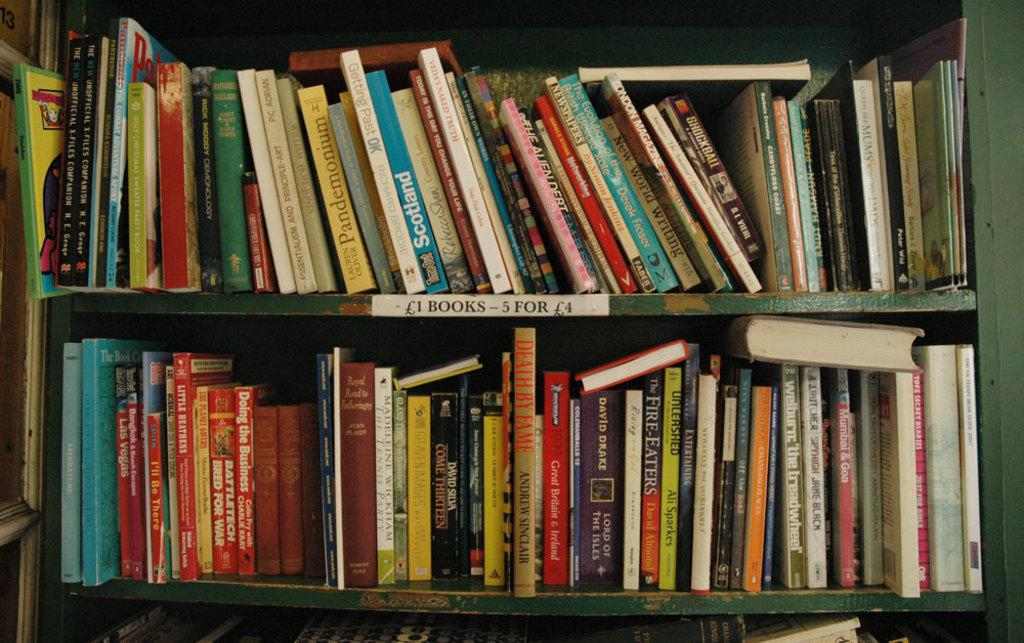Provide a one-sentence caption for the provided image. Varieties of used books are for sale for 1£ a book for 4£ for 5 books. 